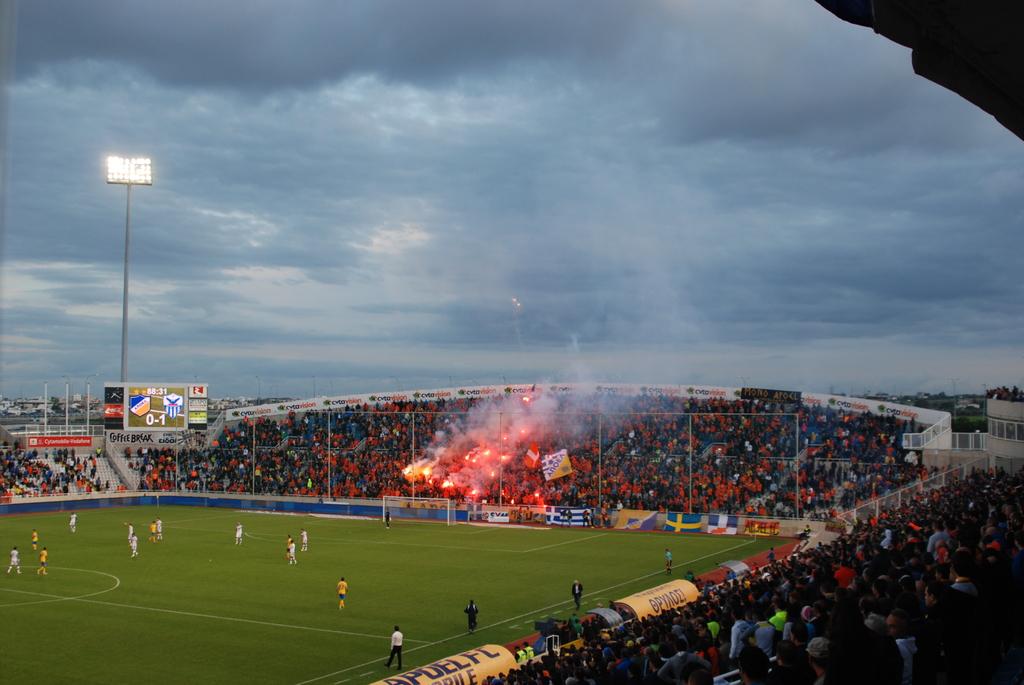What is the score?
Your answer should be compact. 0-1. 